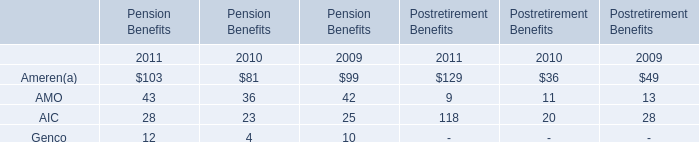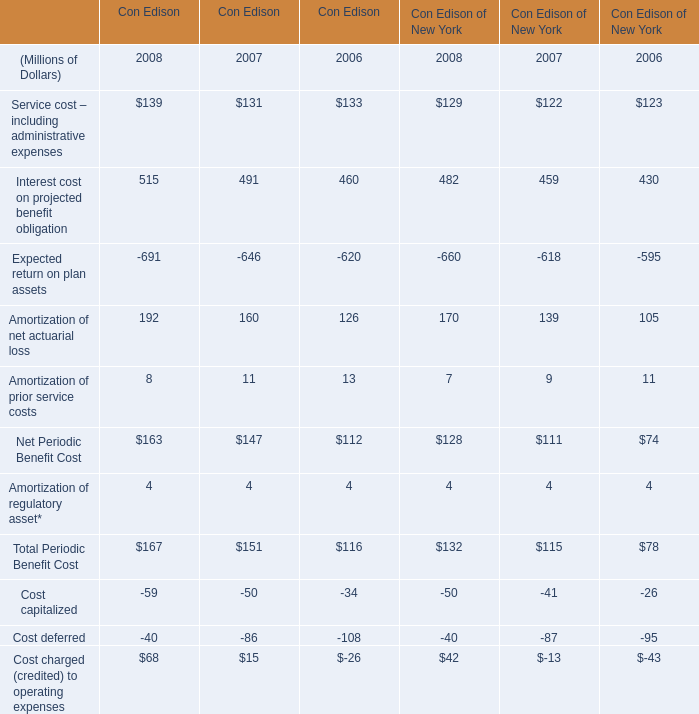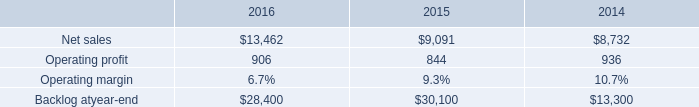What will Interest cost on projected benefit obligation in Con Edison be like in 2009 if it develops with the same increasing rate as current? (in millions) 
Computations: ((1 + ((515 - 491) / 491)) * 515)
Answer: 540.17312. 